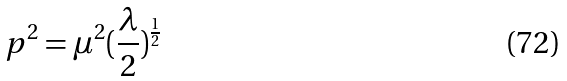Convert formula to latex. <formula><loc_0><loc_0><loc_500><loc_500>p ^ { 2 } = \mu ^ { 2 } ( \frac { \lambda } { 2 } ) ^ { \frac { 1 } { 2 } }</formula> 